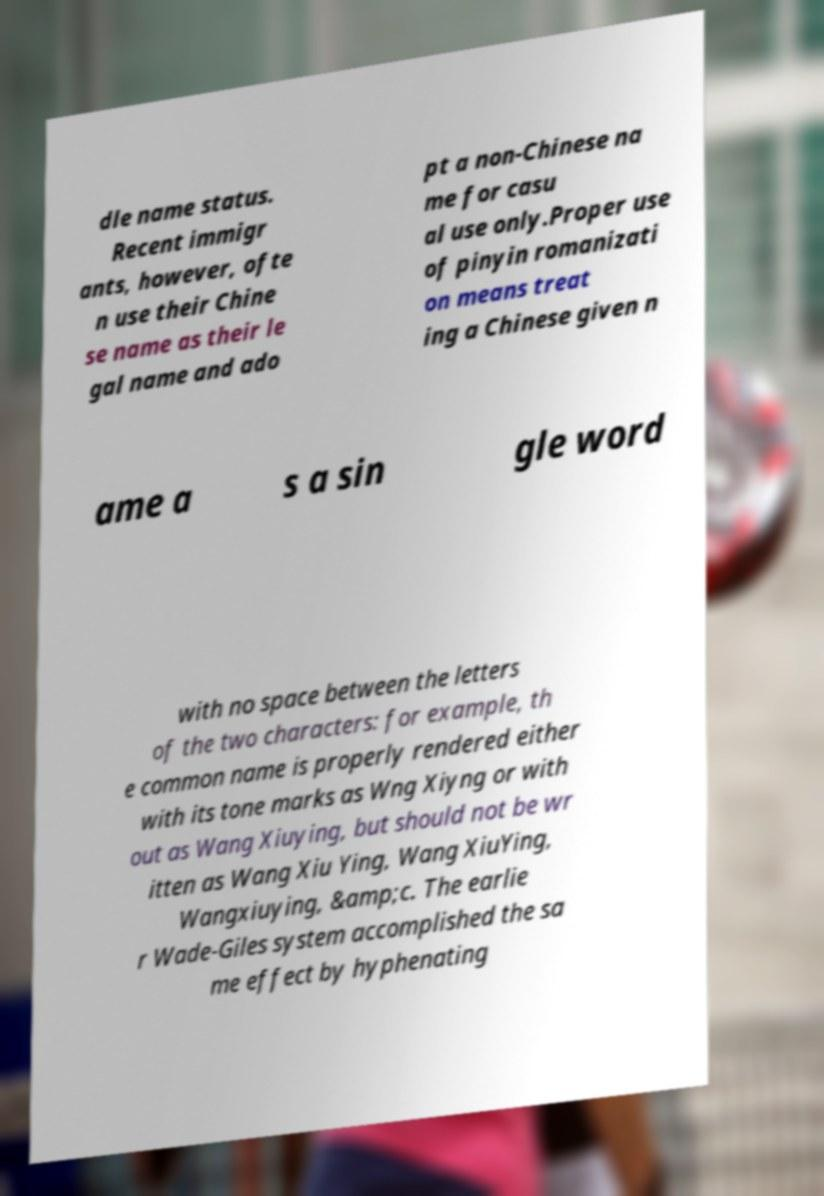Could you extract and type out the text from this image? dle name status. Recent immigr ants, however, ofte n use their Chine se name as their le gal name and ado pt a non-Chinese na me for casu al use only.Proper use of pinyin romanizati on means treat ing a Chinese given n ame a s a sin gle word with no space between the letters of the two characters: for example, th e common name is properly rendered either with its tone marks as Wng Xiyng or with out as Wang Xiuying, but should not be wr itten as Wang Xiu Ying, Wang XiuYing, Wangxiuying, &amp;c. The earlie r Wade-Giles system accomplished the sa me effect by hyphenating 